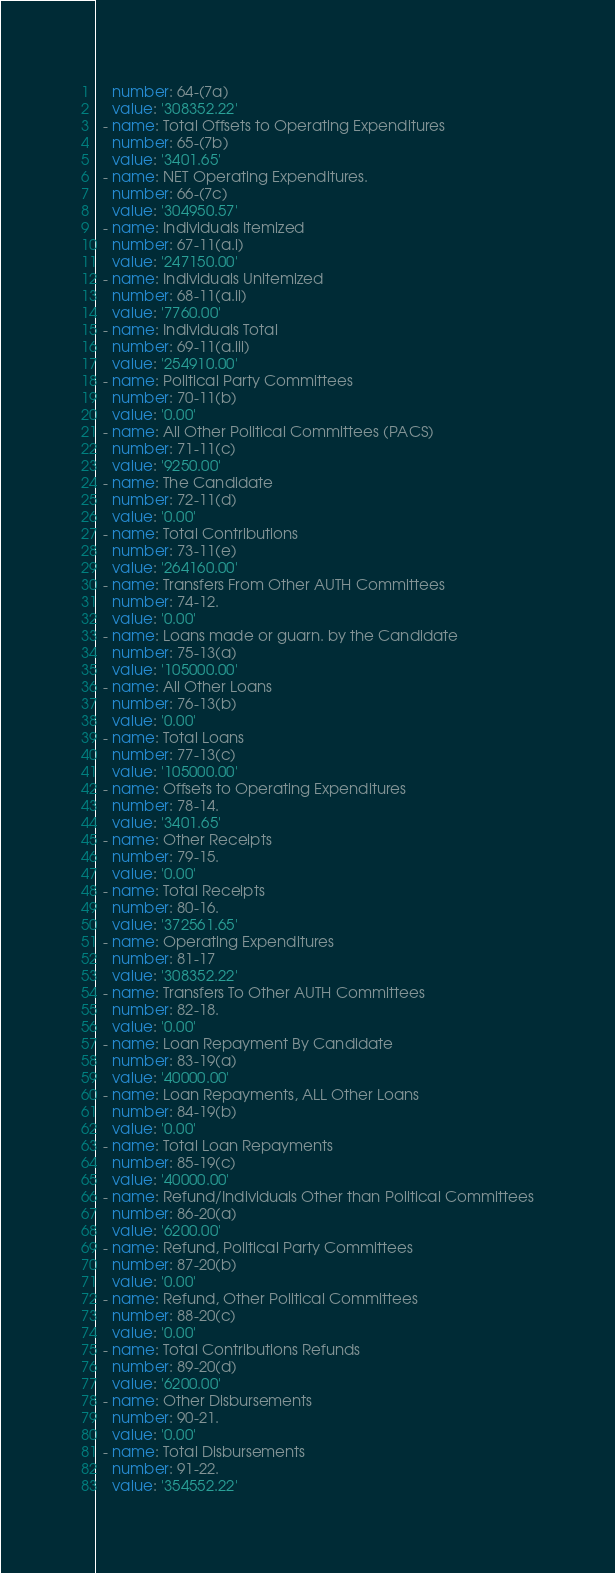Convert code to text. <code><loc_0><loc_0><loc_500><loc_500><_YAML_>    number: 64-(7a)
    value: '308352.22'
  - name: Total Offsets to Operating Expenditures
    number: 65-(7b)
    value: '3401.65'
  - name: NET Operating Expenditures.
    number: 66-(7c)
    value: '304950.57'
  - name: Individuals Itemized
    number: 67-11(a.i)
    value: '247150.00'
  - name: Individuals Unitemized
    number: 68-11(a.ii)
    value: '7760.00'
  - name: Individuals Total
    number: 69-11(a.iii)
    value: '254910.00'
  - name: Political Party Committees
    number: 70-11(b)
    value: '0.00'
  - name: All Other Political Committees (PACS)
    number: 71-11(c)
    value: '9250.00'
  - name: The Candidate
    number: 72-11(d)
    value: '0.00'
  - name: Total Contributions
    number: 73-11(e)
    value: '264160.00'
  - name: Transfers From Other AUTH Committees
    number: 74-12.
    value: '0.00'
  - name: Loans made or guarn. by the Candidate
    number: 75-13(a)
    value: '105000.00'
  - name: All Other Loans
    number: 76-13(b)
    value: '0.00'
  - name: Total Loans
    number: 77-13(c)
    value: '105000.00'
  - name: Offsets to Operating Expenditures
    number: 78-14.
    value: '3401.65'
  - name: Other Receipts
    number: 79-15.
    value: '0.00'
  - name: Total Receipts
    number: 80-16.
    value: '372561.65'
  - name: Operating Expenditures
    number: 81-17
    value: '308352.22'
  - name: Transfers To Other AUTH Committees
    number: 82-18.
    value: '0.00'
  - name: Loan Repayment By Candidate
    number: 83-19(a)
    value: '40000.00'
  - name: Loan Repayments, ALL Other Loans
    number: 84-19(b)
    value: '0.00'
  - name: Total Loan Repayments
    number: 85-19(c)
    value: '40000.00'
  - name: Refund/Individuals Other than Political Committees
    number: 86-20(a)
    value: '6200.00'
  - name: Refund, Political Party Committees
    number: 87-20(b)
    value: '0.00'
  - name: Refund, Other Political Committees
    number: 88-20(c)
    value: '0.00'
  - name: Total Contributions Refunds
    number: 89-20(d)
    value: '6200.00'
  - name: Other Disbursements
    number: 90-21.
    value: '0.00'
  - name: Total Disbursements
    number: 91-22.
    value: '354552.22'</code> 